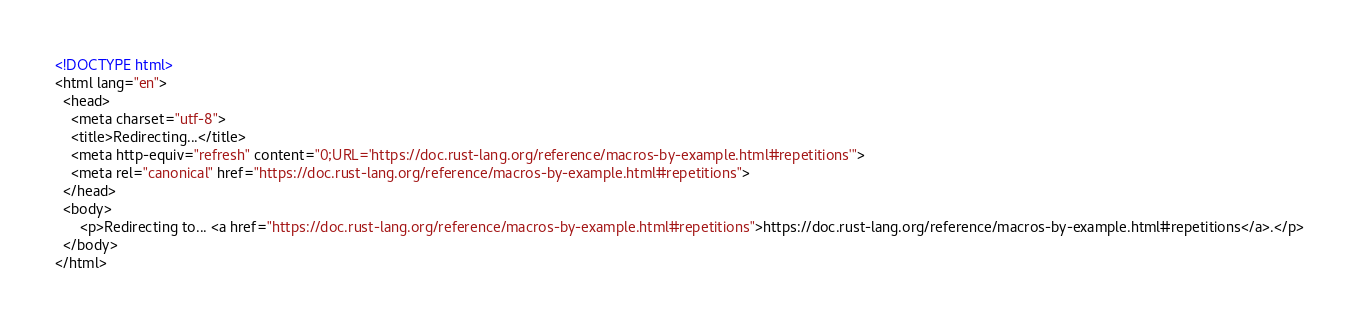<code> <loc_0><loc_0><loc_500><loc_500><_HTML_><!DOCTYPE html>
<html lang="en">
  <head>
    <meta charset="utf-8">
    <title>Redirecting...</title>
    <meta http-equiv="refresh" content="0;URL='https://doc.rust-lang.org/reference/macros-by-example.html#repetitions'">
    <meta rel="canonical" href="https://doc.rust-lang.org/reference/macros-by-example.html#repetitions">
  </head>
  <body>
      <p>Redirecting to... <a href="https://doc.rust-lang.org/reference/macros-by-example.html#repetitions">https://doc.rust-lang.org/reference/macros-by-example.html#repetitions</a>.</p>
  </body>
</html>
</code> 